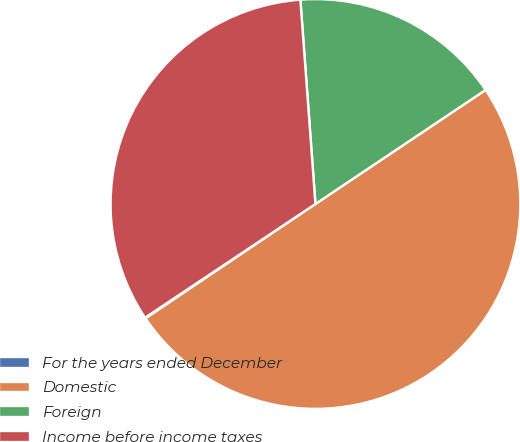Convert chart. <chart><loc_0><loc_0><loc_500><loc_500><pie_chart><fcel>For the years ended December<fcel>Domestic<fcel>Foreign<fcel>Income before income taxes<nl><fcel>0.07%<fcel>49.96%<fcel>16.77%<fcel>33.19%<nl></chart> 